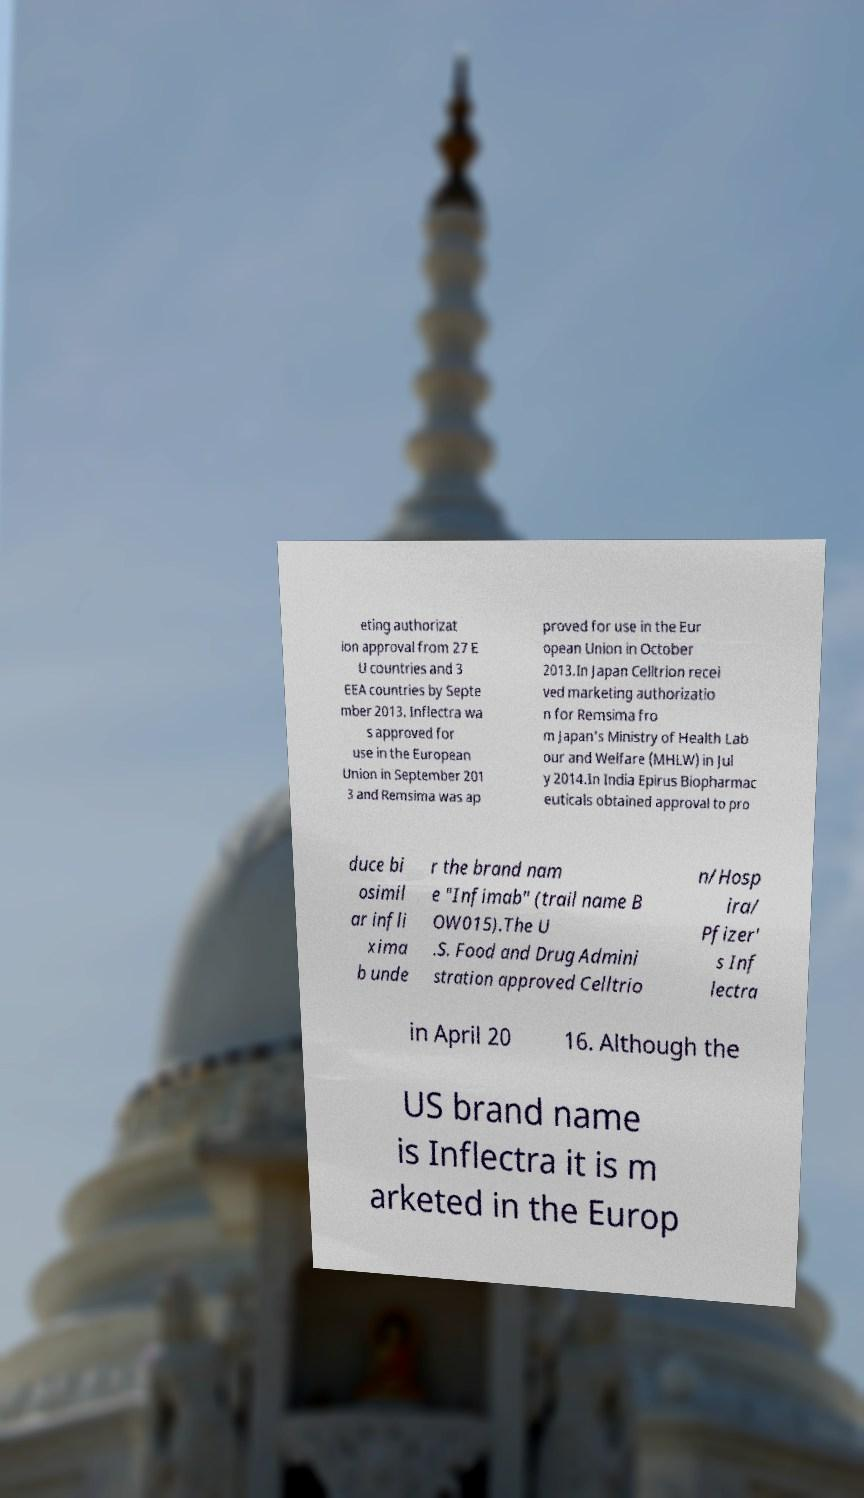Could you extract and type out the text from this image? eting authorizat ion approval from 27 E U countries and 3 EEA countries by Septe mber 2013. Inflectra wa s approved for use in the European Union in September 201 3 and Remsima was ap proved for use in the Eur opean Union in October 2013.In Japan Celltrion recei ved marketing authorizatio n for Remsima fro m Japan's Ministry of Health Lab our and Welfare (MHLW) in Jul y 2014.In India Epirus Biopharmac euticals obtained approval to pro duce bi osimil ar infli xima b unde r the brand nam e "Infimab" (trail name B OW015).The U .S. Food and Drug Admini stration approved Celltrio n/Hosp ira/ Pfizer' s Inf lectra in April 20 16. Although the US brand name is Inflectra it is m arketed in the Europ 